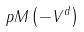Convert formula to latex. <formula><loc_0><loc_0><loc_500><loc_500>p M \left ( { - { V } ^ { d } } \right )</formula> 